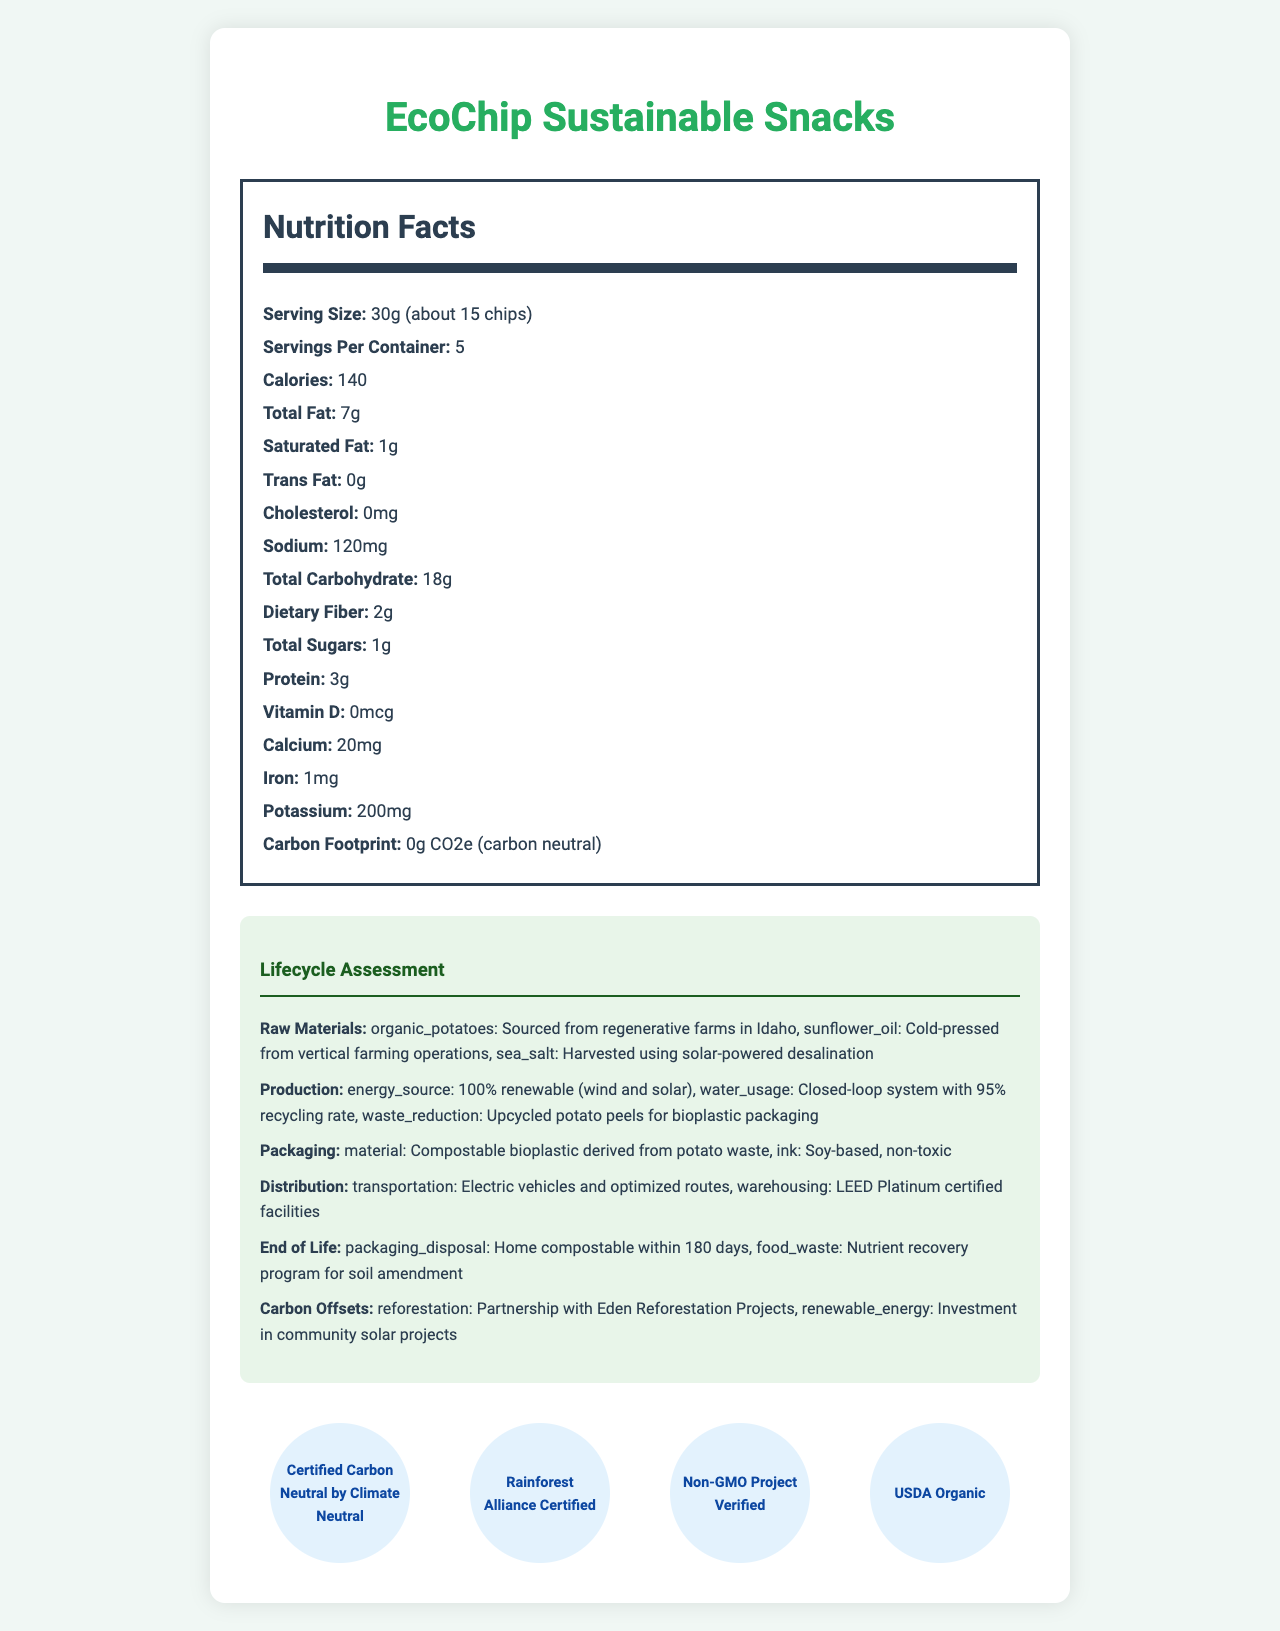what is the total fat per serving? The document lists the total fat content as 7g per 30g serving.
Answer: 7g how many calories are in the entire container? The document states there are 5 servings per container, with 140 calories per serving. 5 servings x 140 calories = 700 calories.
Answer: 700 calories what is the primary source of energy in production? Under the production section of the lifecycle assessment, it mentions that energy sourcing is from 100% renewable sources, specifically wind and solar.
Answer: 100% renewable (wind and solar) describe the end-of-life options for the packaging. The document states that the packaging is home compostable within 180 days, under the end-of-life section.
Answer: Home compostable within 180 days what ethical considerations are highlighted in the document? The ethical considerations section lists living wages and profit-sharing for employees, local job creation, support for pollinator habitats and crop diversity, and blockchain-tracked supply chain for transparency.
Answer: Fair labor, community impact, biodiversity, transparency which of the following certifications does EcoChip possess? A. Certified Carbon Neutral B. Fair Trade Certified C. Non-GMO Project Verified D. USDA Organic According to the sustainability certifications section, EcoChip is Certified Carbon Neutral, Non-GMO Project Verified, and USDA Organic.
Answer: B where are the organic potatoes sourced from? A. California B. Idaho C. Oregon D. Washington The document specifies that the organic potatoes are sourced from regenerative farms in Idaho under the raw materials section.
Answer: B is the sodium content per serving above 100mg? The document lists the sodium content as 120mg per serving, which is above 100mg.
Answer: Yes summarize the document in one sentence. It includes sections on nutritional facts, lifecycle assessment from raw materials to end-of-life, ethical aspects, certifications, and technical innovations.
Answer: The document provides detailed nutritional information, lifecycle assessment, ethical considerations, sustainability certifications, and engineering innovations for a carbon-neutral snack food called EcoChip Sustainable Snacks. what is the percentage of dietary fiber in each serving? The document provides the amount of dietary fiber (2g), but not the daily value percentage (%DV) which would be needed to calculate the percentage.
Answer: Not enough information how are the lifecycle assessment data points distributed? The document divides the assessment into different stages of the product lifecycle, detailing specifics within categories like raw materials, production, packaging, distribution, end of life, and carbon offsets.
Answer: Across categories like raw materials, production, packaging, distribution, end of life, and carbon offsets 